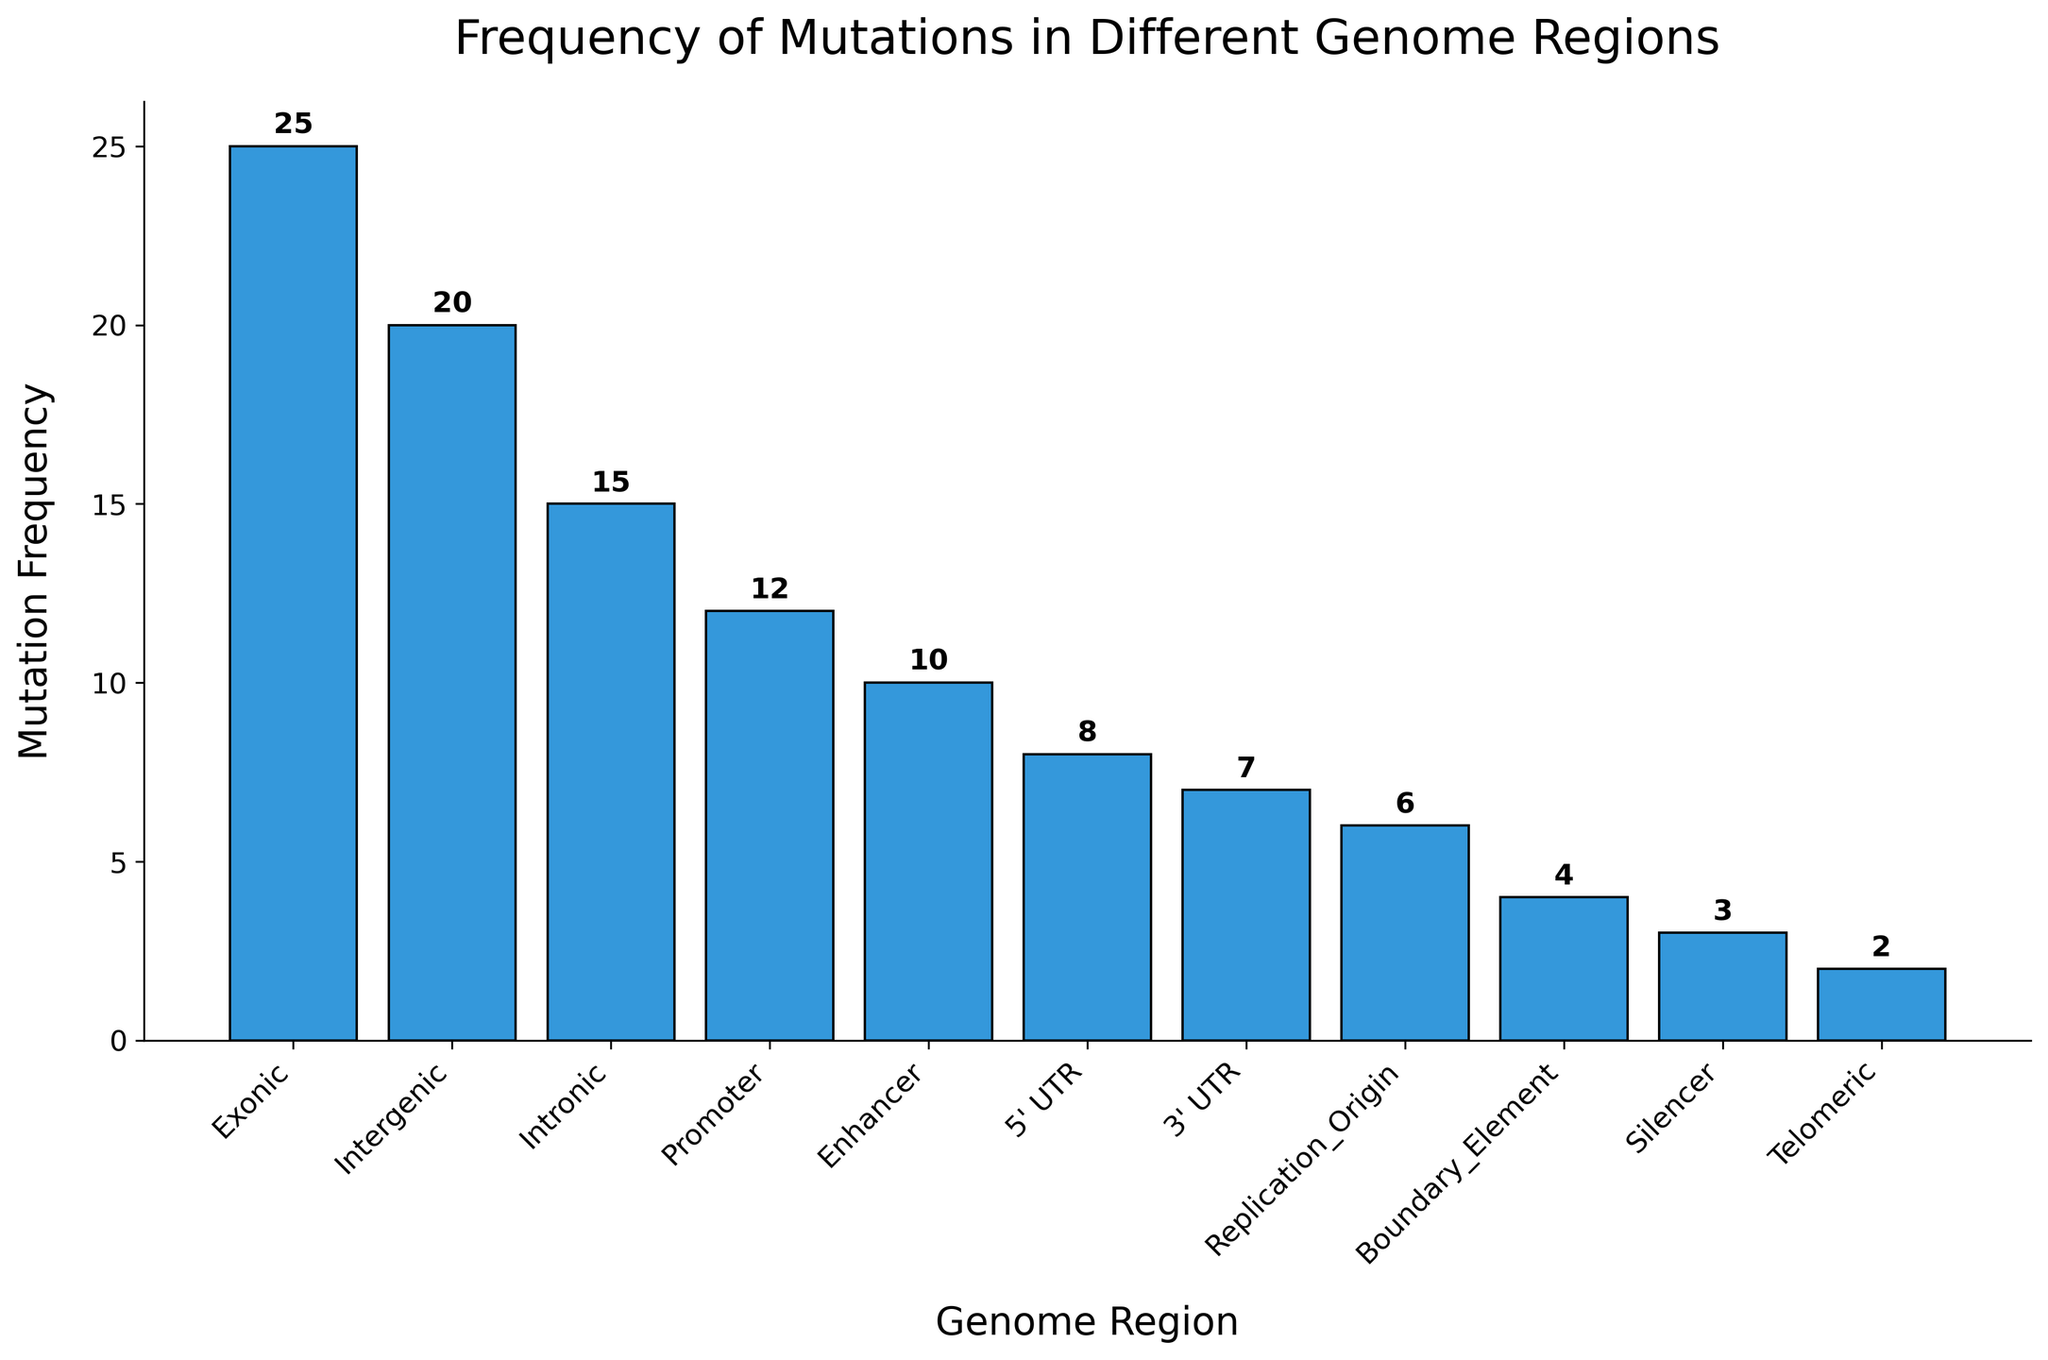What is the most frequently mutated genome region? The bar representing the "Exonic" region is the tallest, indicating it has the highest mutation frequency.
Answer: Exonic Which genome region has the lowest frequency of mutations? The bar representing the "Telomeric" region is the shortest, indicating it has the lowest mutation frequency.
Answer: Telomeric How many genome regions have a mutation frequency greater than 10? The regions with frequencies greater than 10 are Promoter, Exonic, Intronic, and Intergenic.
Answer: 4 Compare the frequency of mutations in the Promoter and Enhancer regions. Which one is higher and by how much? The Promoter region has a frequency of 12 and the Enhancer region has a frequency of 10. The Promoter has a higher frequency by 2.
Answer: Promoter by 2 What is the combined mutation frequency of the 5' UTR and 3' UTR regions? The 5' UTR has a frequency of 8 and the 3' UTR has a frequency of 7. Adding them together gives 8 + 7.
Answer: 15 What is the average mutation frequency across all genome regions? Sum the frequencies: 12 + 8 + 25 + 15 + 7 + 20 + 10 + 3 + 4 + 6 + 2 = 112. There are 11 regions. Average = 112 / 11.
Answer: 10.2 Compare the frequencies of the Intergenic and Intronic regions. How do they differ? The Intergenic region has a frequency of 20 and the Intronic region has a frequency of 15. They differ by 5.
Answer: Differ by 5 How many regions have a mutation frequency less than or equal to 7? The regions with frequencies less than or equal to 7 are 3' UTR, Silencer, Boundary_Element, Replication_Origin, and Telomeric.
Answer: 5 What is the total mutation frequency of non-coding regions (Promoter, 5’ UTR, 3’ UTR, Intergenic, Enhancer, Silencer, Boundary_Element, Replication_Origin, Telomeric)? The frequencies are: 12 (Promoter) + 8 (5' UTR) + 7 (3' UTR) + 20 (Intergenic) + 10 (Enhancer) + 3 (Silencer) + 4 (Boundary_Element) + 6 (Replication_Origin) + 2 (Telomeric). Adding them together gives 72.
Answer: 72 What is the difference in mutation frequency between the Exonic and Silencer regions? The Exonic region has a frequency of 25 and the Silencer region has a frequency of 3. The difference is 25 - 3.
Answer: 22 